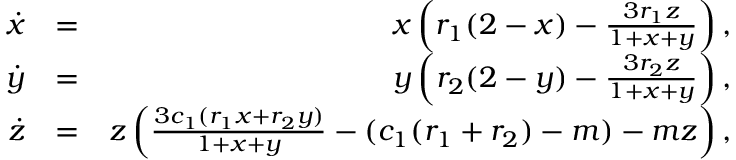<formula> <loc_0><loc_0><loc_500><loc_500>\begin{array} { r l r } { \dot { x } } & { = } & { x \left ( r _ { 1 } ( 2 - x ) - \frac { 3 r _ { 1 } z } { 1 + x + y } \right ) , } \\ { \dot { y } } & { = } & { y \left ( r _ { 2 } ( 2 - y ) - \frac { 3 r _ { 2 } z } { 1 + x + y } \right ) , } \\ { \dot { z } } & { = } & { z \left ( \frac { 3 c _ { 1 } ( r _ { 1 } x + r _ { 2 } y ) } { 1 + x + y } - ( c _ { 1 } ( r _ { 1 } + r _ { 2 } ) - m ) - m z \right ) , } \end{array}</formula> 